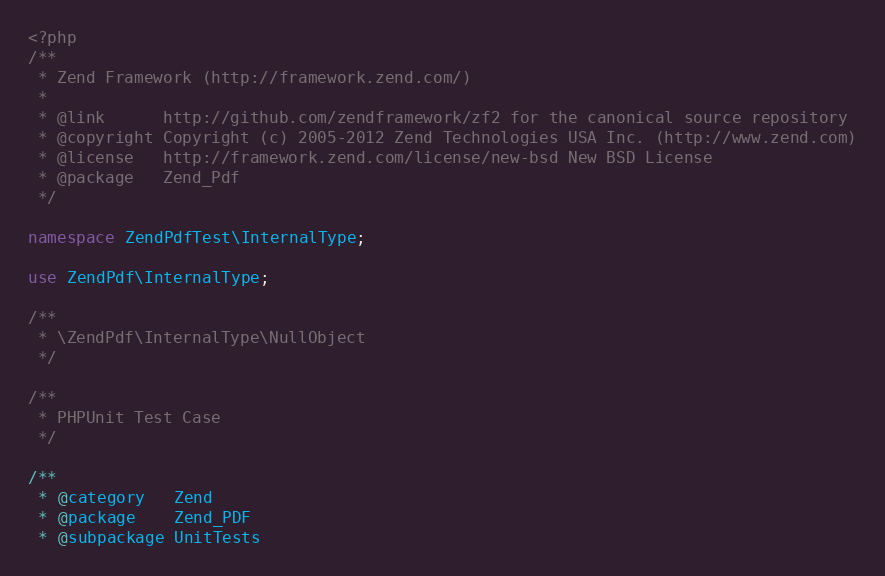<code> <loc_0><loc_0><loc_500><loc_500><_PHP_><?php
/**
 * Zend Framework (http://framework.zend.com/)
 *
 * @link      http://github.com/zendframework/zf2 for the canonical source repository
 * @copyright Copyright (c) 2005-2012 Zend Technologies USA Inc. (http://www.zend.com)
 * @license   http://framework.zend.com/license/new-bsd New BSD License
 * @package   Zend_Pdf
 */

namespace ZendPdfTest\InternalType;

use ZendPdf\InternalType;

/**
 * \ZendPdf\InternalType\NullObject
 */

/**
 * PHPUnit Test Case
 */

/**
 * @category   Zend
 * @package    Zend_PDF
 * @subpackage UnitTests</code> 